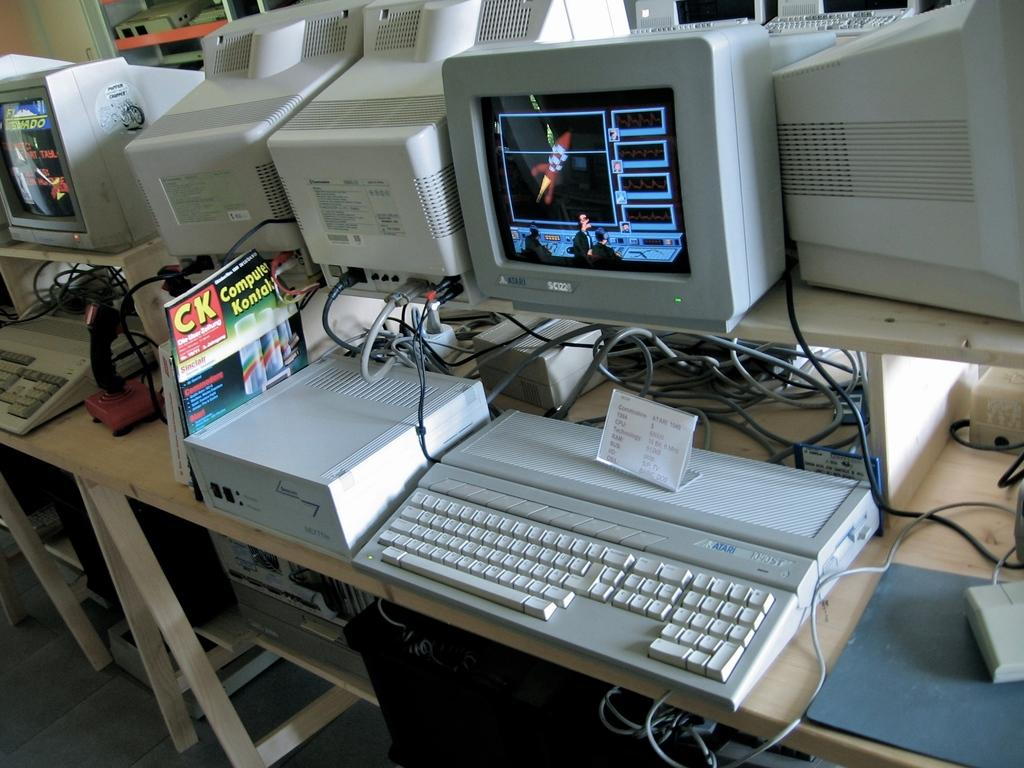<image>
Provide a brief description of the given image. A computer monitor with the logo for atari is displaying a game on its screen. 